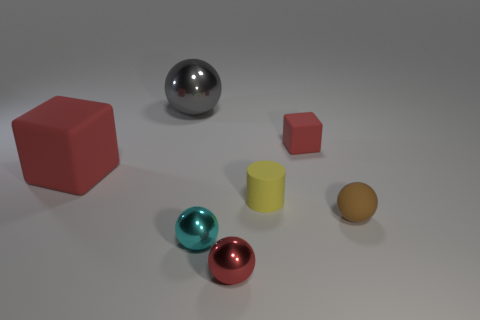Subtract all small matte balls. How many balls are left? 3 Add 1 big blue rubber blocks. How many objects exist? 8 Subtract all cyan balls. How many balls are left? 3 Subtract 1 balls. How many balls are left? 3 Subtract 0 purple cylinders. How many objects are left? 7 Subtract all spheres. How many objects are left? 3 Subtract all yellow spheres. Subtract all blue cylinders. How many spheres are left? 4 Subtract all gray cylinders. How many brown spheres are left? 1 Subtract all cylinders. Subtract all tiny red balls. How many objects are left? 5 Add 1 rubber cylinders. How many rubber cylinders are left? 2 